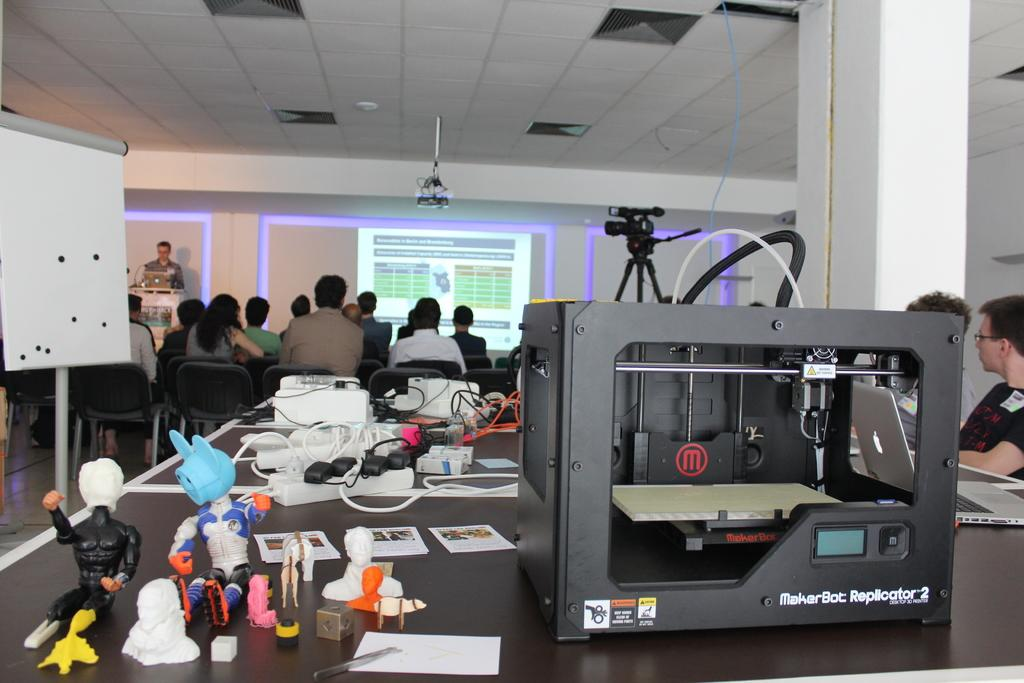<image>
Offer a succinct explanation of the picture presented. A MakerBot Replicator in the back of a room with a seminar going on. 